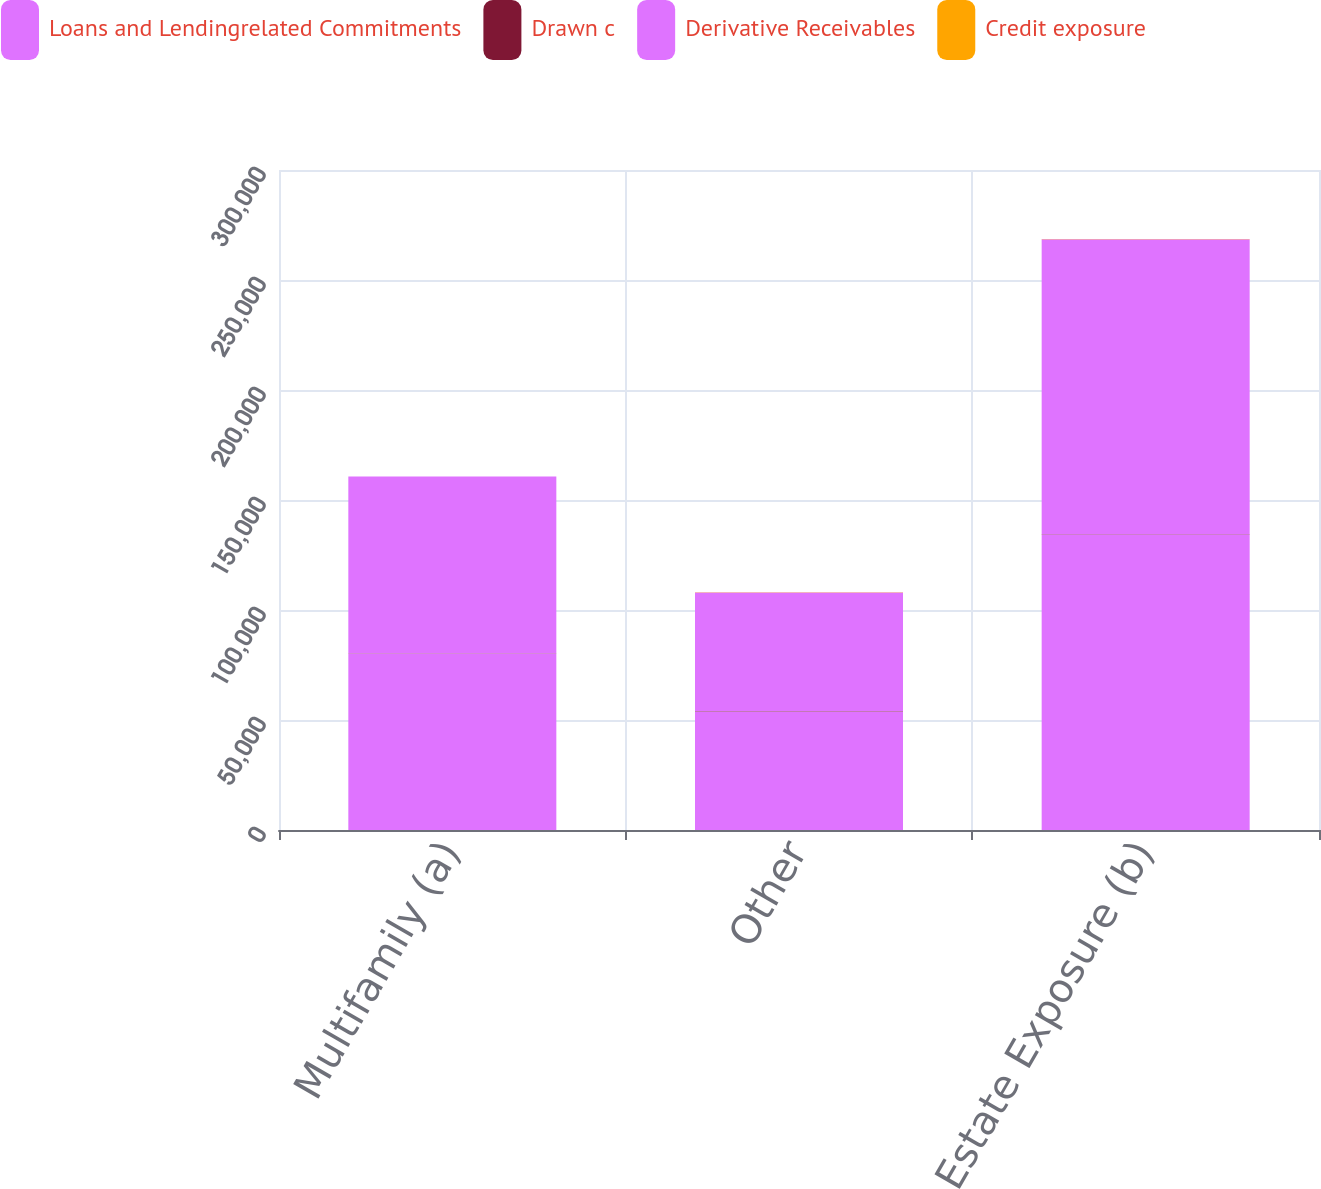Convert chart. <chart><loc_0><loc_0><loc_500><loc_500><stacked_bar_chart><ecel><fcel>Multifamily (a)<fcel>Other<fcel>Total Real Estate Exposure (b)<nl><fcel>Loans and Lendingrelated Commitments<fcel>80280<fcel>53801<fcel>134081<nl><fcel>Drawn c<fcel>34<fcel>172<fcel>207<nl><fcel>Derivative Receivables<fcel>80314<fcel>53973<fcel>134287<nl><fcel>Credit exposure<fcel>82<fcel>72<fcel>78<nl></chart> 